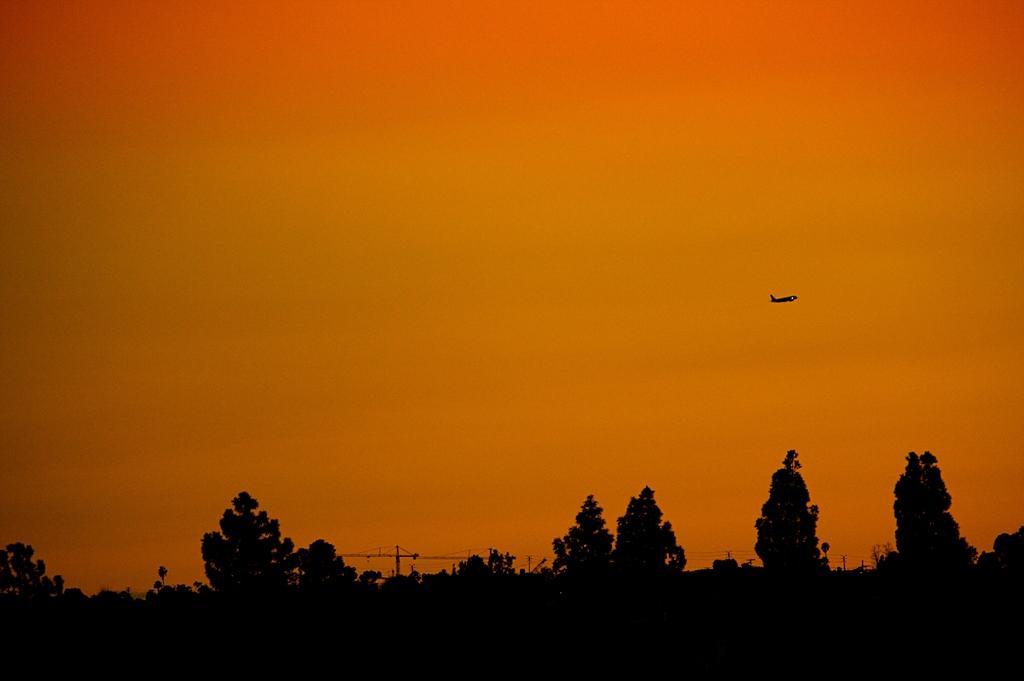How would you summarize this image in a sentence or two? At the bottom of the image there are trees. There is a aeroplane. In the background of the image there is a sky. 